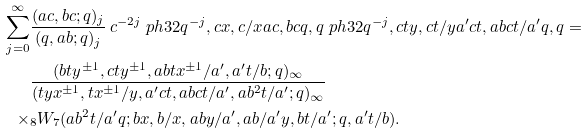<formula> <loc_0><loc_0><loc_500><loc_500>\sum _ { j = 0 } ^ { \infty } & \frac { ( a c , b c ; q ) _ { j } } { ( q , a b ; q ) _ { j } } \, c ^ { - 2 j } \ p h { 3 } { 2 } { q ^ { - j } , c x , c / x } { a c , b c } { q , q } \ p h { 3 } { 2 } { q ^ { - j } , c t y , c t / y } { a ^ { \prime } c t , a b c t / a ^ { \prime } } { q , q } = \\ & \frac { ( b t y ^ { \pm 1 } , c t y ^ { \pm 1 } , a b t x ^ { \pm 1 } / a ^ { \prime } , a ^ { \prime } t / b ; q ) _ { \infty } } { ( t y x ^ { \pm 1 } , t x ^ { \pm 1 } / y , a ^ { \prime } c t , a b c t / a ^ { \prime } , a b ^ { 2 } t / a ^ { \prime } ; q ) _ { \infty } } \\ \times & _ { 8 } W _ { 7 } ( a b ^ { 2 } t / a ^ { \prime } q ; b x , b / x , a b y / a ^ { \prime } , a b / a ^ { \prime } y , b t / a ^ { \prime } ; q , a ^ { \prime } t / b ) .</formula> 